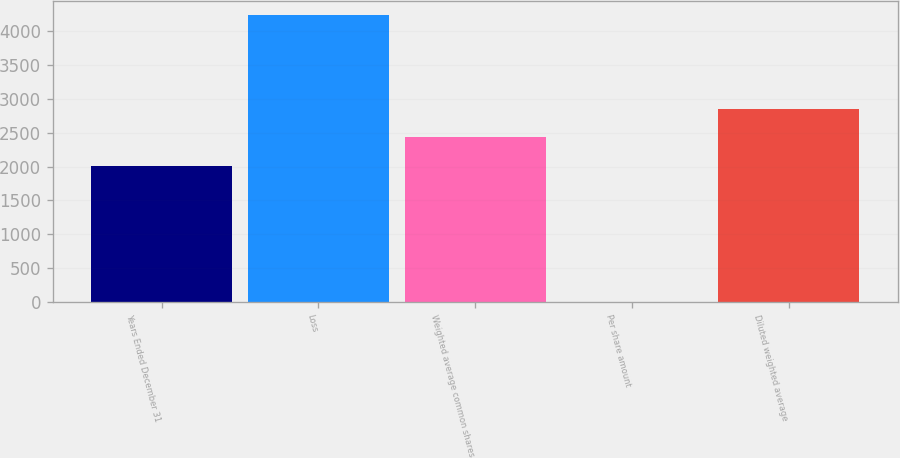Convert chart to OTSL. <chart><loc_0><loc_0><loc_500><loc_500><bar_chart><fcel>Years Ended December 31<fcel>Loss<fcel>Weighted average common shares<fcel>Per share amount<fcel>Diluted weighted average<nl><fcel>2008<fcel>4244<fcel>2432.21<fcel>1.87<fcel>2856.42<nl></chart> 